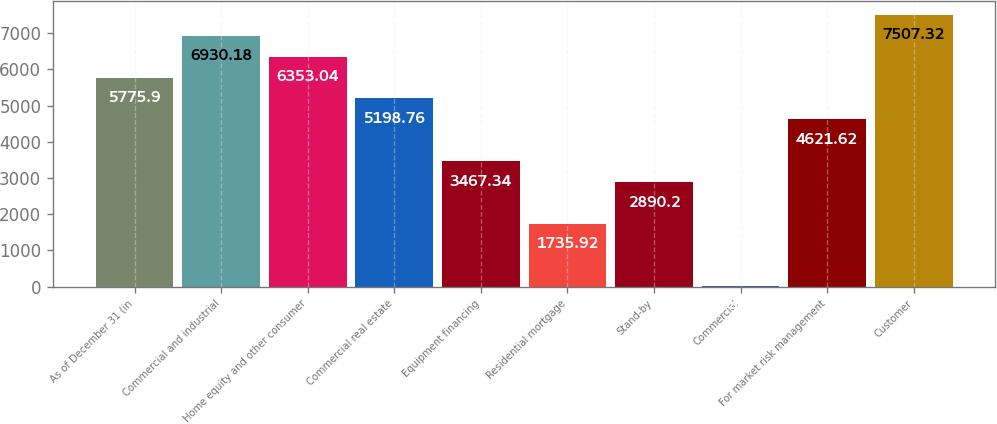Convert chart to OTSL. <chart><loc_0><loc_0><loc_500><loc_500><bar_chart><fcel>As of December 31 (in<fcel>Commercial and industrial<fcel>Home equity and other consumer<fcel>Commercial real estate<fcel>Equipment financing<fcel>Residential mortgage<fcel>Stand-by<fcel>Commercial<fcel>For market risk management<fcel>Customer<nl><fcel>5775.9<fcel>6930.18<fcel>6353.04<fcel>5198.76<fcel>3467.34<fcel>1735.92<fcel>2890.2<fcel>4.5<fcel>4621.62<fcel>7507.32<nl></chart> 